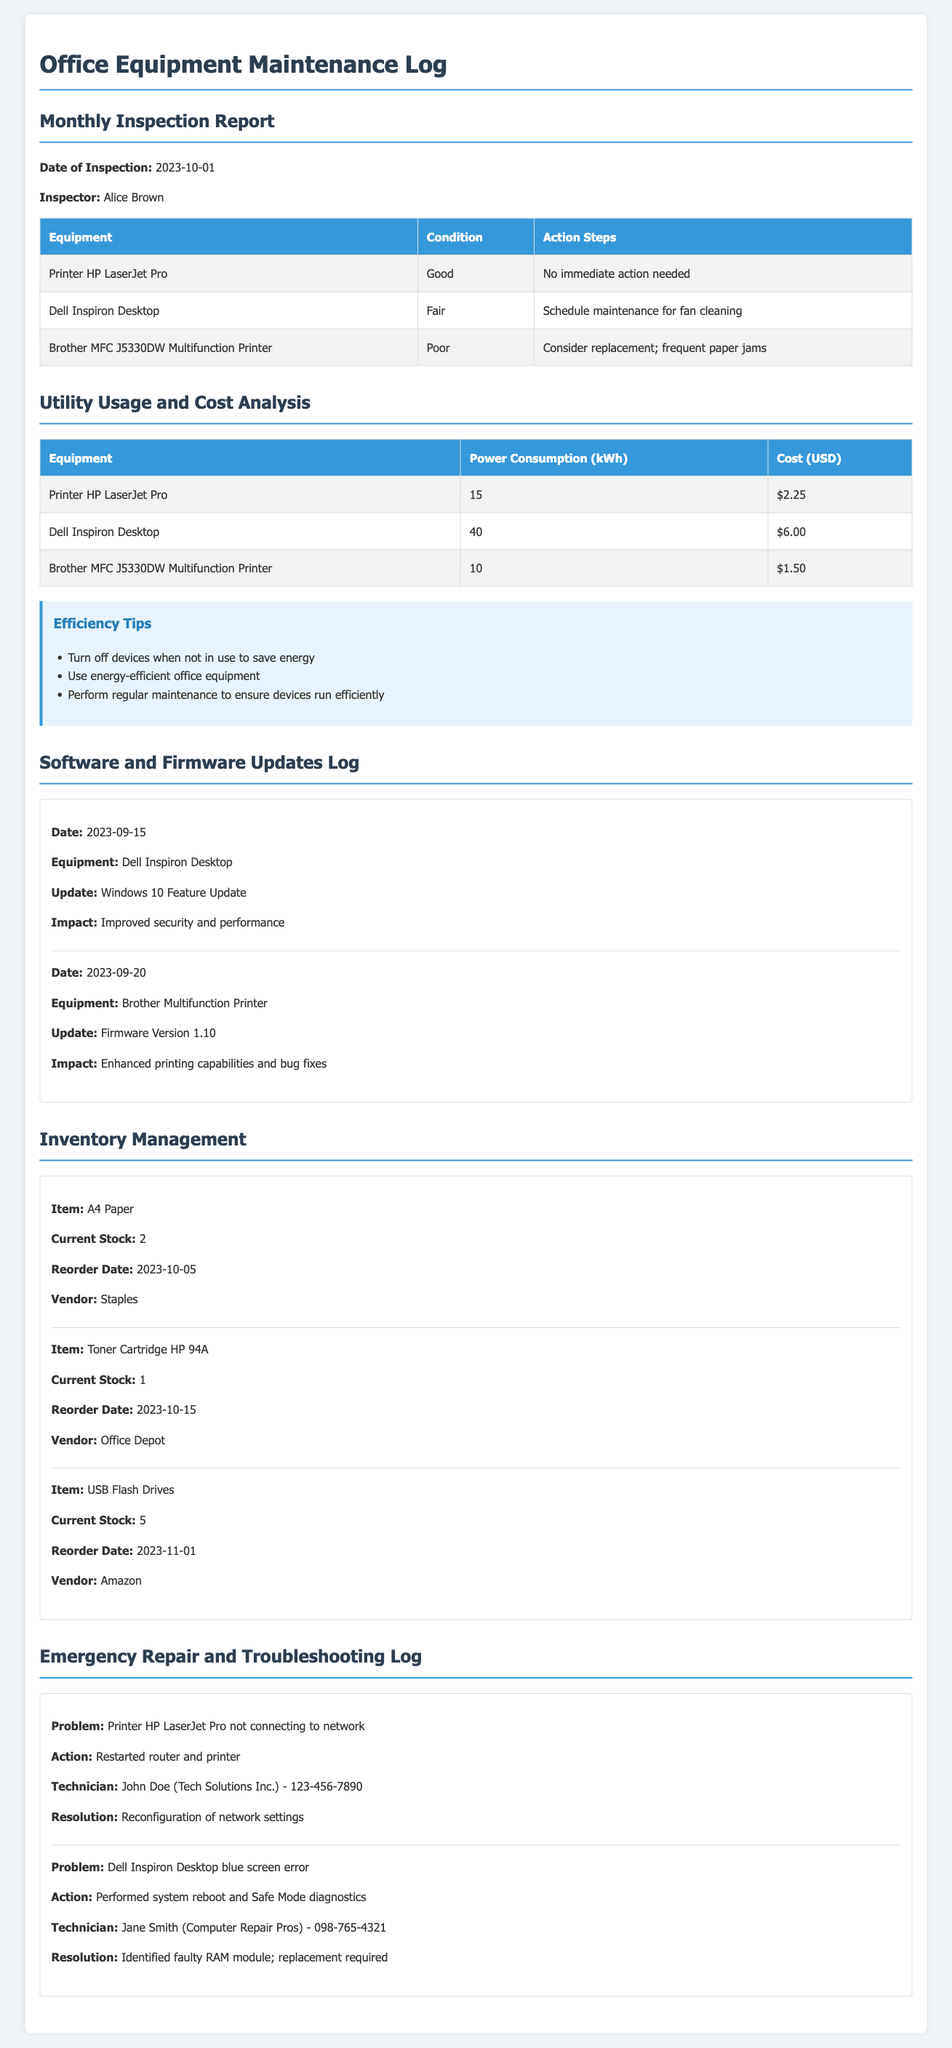What is the date of the last monthly inspection? The last monthly inspection was reported to have happened on October 1, 2023.
Answer: October 1, 2023 Who conducted the office equipment inspection? Alice Brown is named as the inspector for the monthly inspection report.
Answer: Alice Brown What is the condition of the Brother MFC J5330DW Multifunction Printer? The condition of the Brother MFC J5330DW Multifunction Printer is described as poor.
Answer: Poor What action is suggested for the Dell Inspiron Desktop? The action suggested for the Dell Inspiron Desktop is to schedule maintenance for fan cleaning.
Answer: Schedule maintenance for fan cleaning What was the cost of the Printer HP LaserJet Pro's power consumption? The cost for the Printer HP LaserJet Pro's power consumption is reported as $2.25.
Answer: $2.25 How many USB Flash Drives are currently in stock? The current stock level for USB Flash Drives is noted as 5.
Answer: 5 What problem was reported with the Printer HP LaserJet Pro? The problem reported was that the Printer HP LaserJet Pro was not connecting to the network.
Answer: Not connecting to network What is the resolution for the blue screen error on the Dell Inspiron Desktop? The resolution for the blue screen error is identified as a need for replacement of a faulty RAM module.
Answer: Replacement required What efficiency tip is suggested regarding energy usage? One of the efficiency tips is to turn off devices when not in use to save energy.
Answer: Turn off devices when not in use 